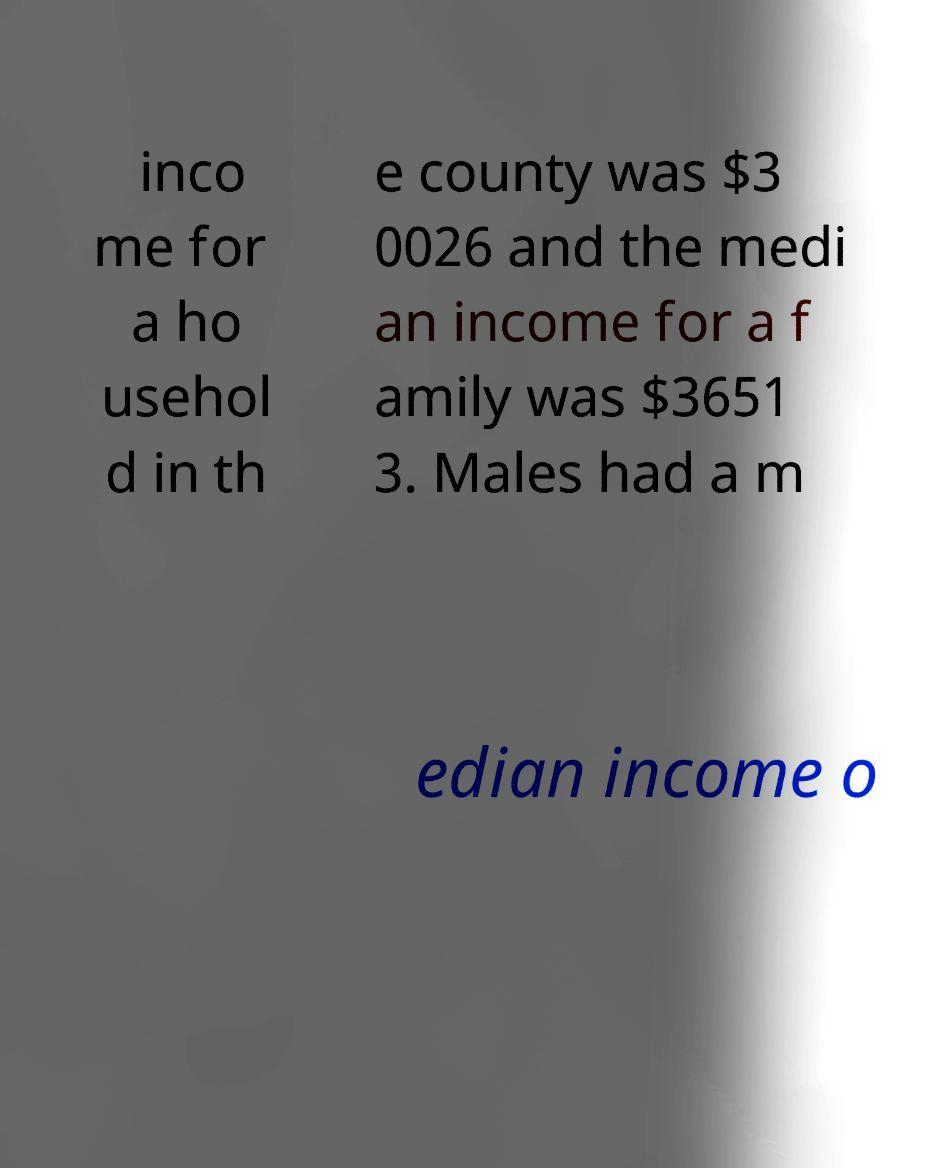Could you assist in decoding the text presented in this image and type it out clearly? inco me for a ho usehol d in th e county was $3 0026 and the medi an income for a f amily was $3651 3. Males had a m edian income o 